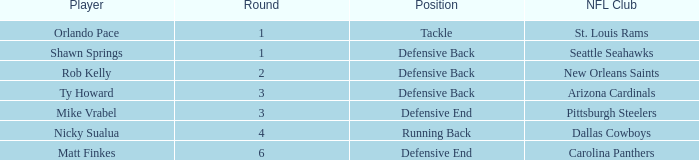What round has a pick less than 189, with arizona cardinals as the NFL club? 3.0. 